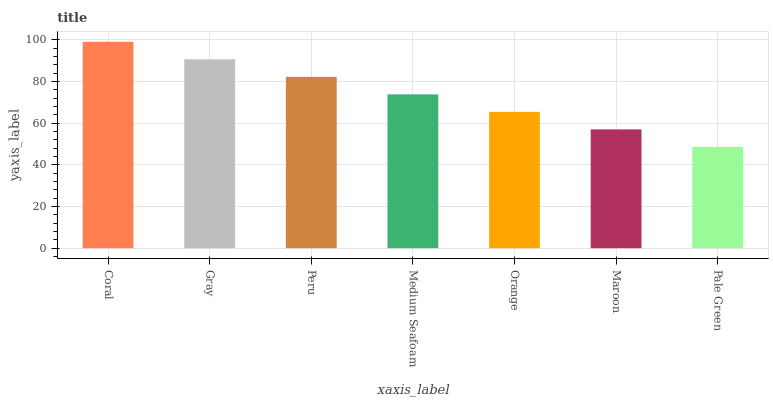Is Pale Green the minimum?
Answer yes or no. Yes. Is Coral the maximum?
Answer yes or no. Yes. Is Gray the minimum?
Answer yes or no. No. Is Gray the maximum?
Answer yes or no. No. Is Coral greater than Gray?
Answer yes or no. Yes. Is Gray less than Coral?
Answer yes or no. Yes. Is Gray greater than Coral?
Answer yes or no. No. Is Coral less than Gray?
Answer yes or no. No. Is Medium Seafoam the high median?
Answer yes or no. Yes. Is Medium Seafoam the low median?
Answer yes or no. Yes. Is Maroon the high median?
Answer yes or no. No. Is Maroon the low median?
Answer yes or no. No. 